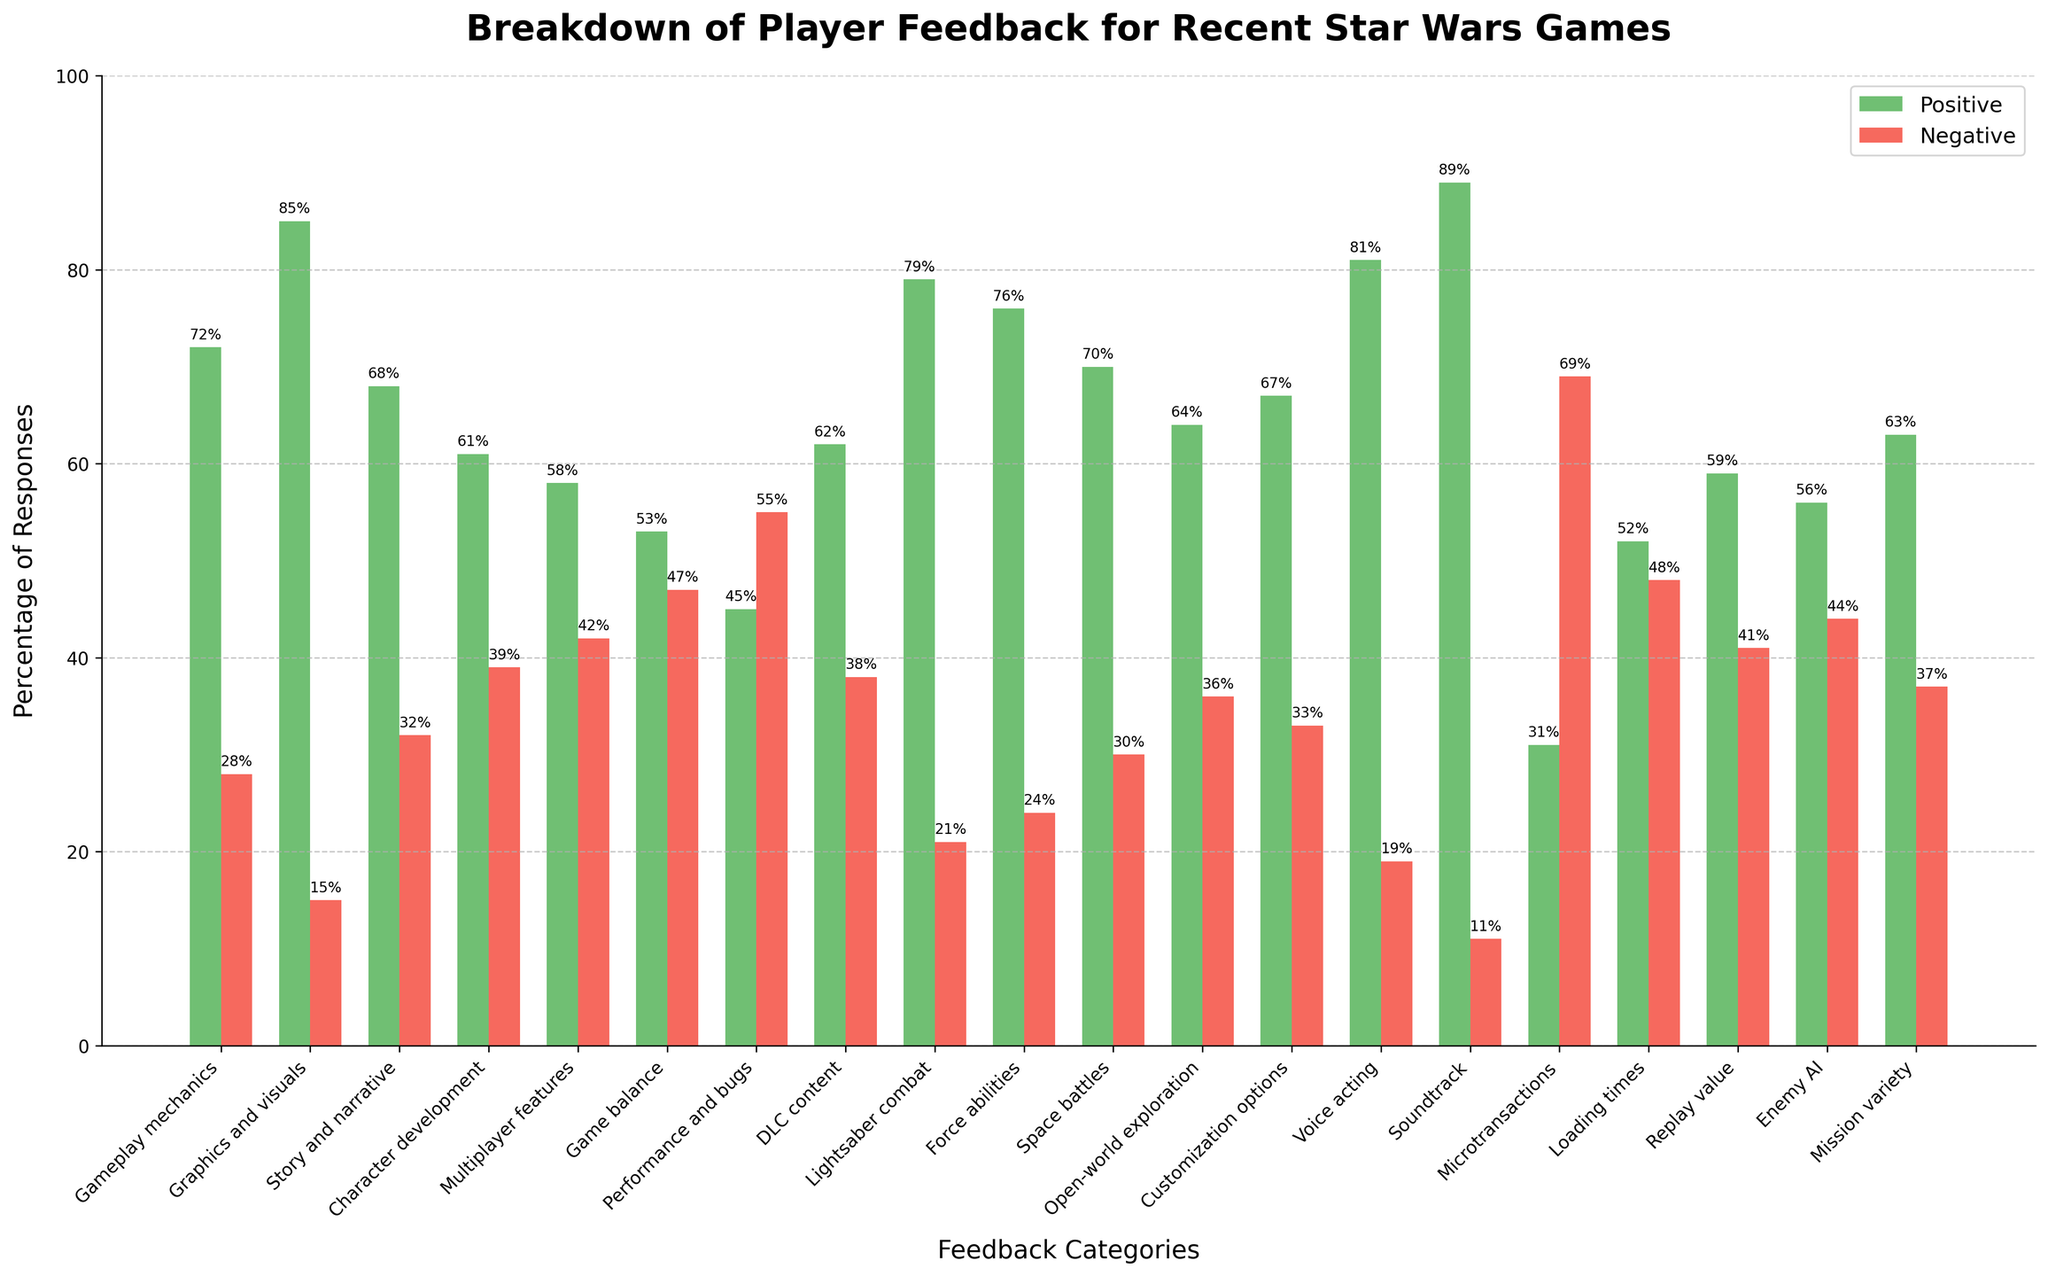Which category received the highest percentage of positive responses? To determine the category with the highest positive responses, we need to identify the bar that extends the furthest on the "Positive" axis. The "Soundtrack" category has the highest bar at 89%.
Answer: Soundtrack Which category had more negative responses than positive? To find this, look for bars where the red (negative) bar is taller than the green (positive) bar. "Microtransactions" has a higher negative bar at 69% compared to the positive bar at 31%.
Answer: Microtransactions How many categories have positive feedback above 70% but below 80%? Categories that fall within this range are identified by examining the height of the green bars. "Lightsaber combat" (79%), "Force abilities" (76%), and "Graphics and visuals" (85%) fit these criteria, but only "Lightsaber combat" and "Force abilities" fall below 80%.
Answer: 2 What is the difference in positive responses between the "Game balance" and "Graphics and visuals" categories? Subtract the "Game balance" positive percentage (53%) from the "Graphics and visuals" positive percentage (85%): 85% - 53% = 32%.
Answer: 32% Which category has the smallest difference between positive and negative responses? We need to look for the categories where the heights of the positive and negative bars are closest. "Loading times" has the smallest difference, with 52% positive and 48% negative, a difference of 4%.
Answer: Loading times Are there more categories with positive feedback above 60% or below? Count categories with positive feedback above 60% and those below. There are 12 categories with above 60% positive feedback and 8 below it.
Answer: Above 60% Which category showed the highest negative feedback and what was the percentage? Identify the category with the tallest red bar. "Performance and bugs" has the highest negative feedback at 55%.
Answer: Performance and bugs Compare the negative feedback percentages of "Gameplay mechanics" and "Multiplayer features." Which has more negative responses and by how much? "Gameplay mechanics" has 28% negative feedback and "Multiplayer features" has 42%. Subtract 28% from 42%: 42% - 28% = 14%.
Answer: Multiplayer features by 14% What is the combined percentage of positive responses for "Lightsaber combat" and "Force abilities"? Sum the positive percentages of both categories: "Lightsaber combat" (79%) and "Force abilities" (76%): 79% + 76% = 155%.
Answer: 155% Which category has the largest discrepancy between positive and negative responses? Locate the largest difference between the green (positive) and red (negative) bars. "Graphics and visuals" with 85% positive and 15% negative has a difference of 70%.
Answer: Graphics and visuals 